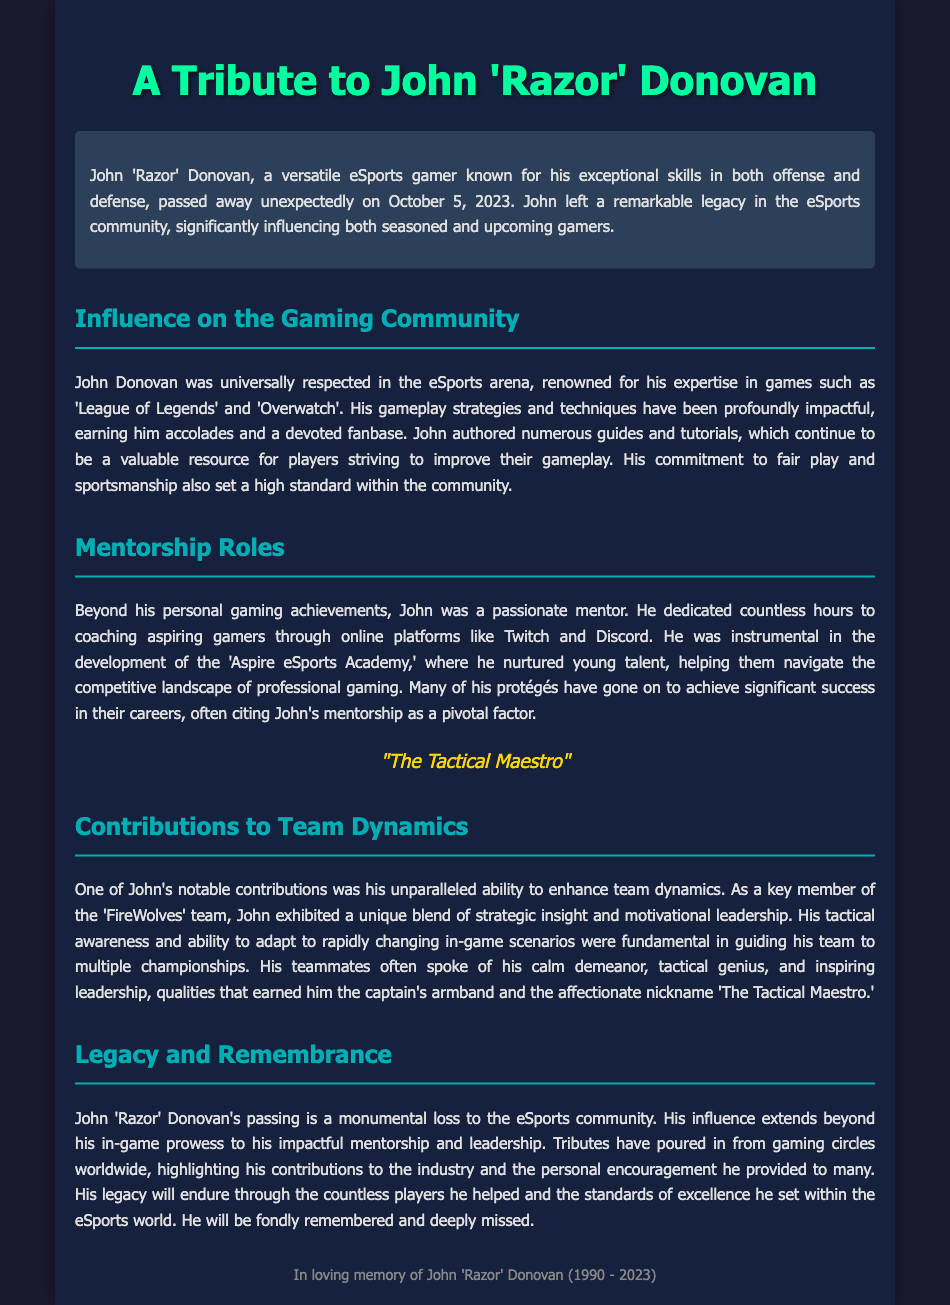What was John's nickname? The document refers to John Donovan as 'Razor' and also mentions the affectionate nickname 'The Tactical Maestro.'
Answer: The Tactical Maestro When did John Donovan pass away? The obituary states that John passed away unexpectedly on October 5, 2023.
Answer: October 5, 2023 Which platforms did John use for mentorship? The document mentions that John dedicated time to coaching through online platforms including Twitch and Discord.
Answer: Twitch and Discord What notable team was John a part of? The obituary highlights John's role as a key member of the 'FireWolves' team.
Answer: FireWolves How many hours did John dedicate to coaching aspiring gamers? The document states that he dedicated countless hours, indicating a large, unspecified number.
Answer: Countless What did John influence besides gaming techniques? John influenced fair play and sportsmanship standards within the gaming community.
Answer: Fair play and sportsmanship Which academy did John help develop? The document mentions that John was instrumental in the development of the 'Aspire eSports Academy.'
Answer: Aspire eSports Academy What role did John most notably exhibit in team dynamics? The obituary describes John's role as a motivational leader within his team, promoting teamwork and strategy.
Answer: Motivational leader What year was John born? The obituary mentions John 'Razor' Donovan's birth year as 1990.
Answer: 1990 